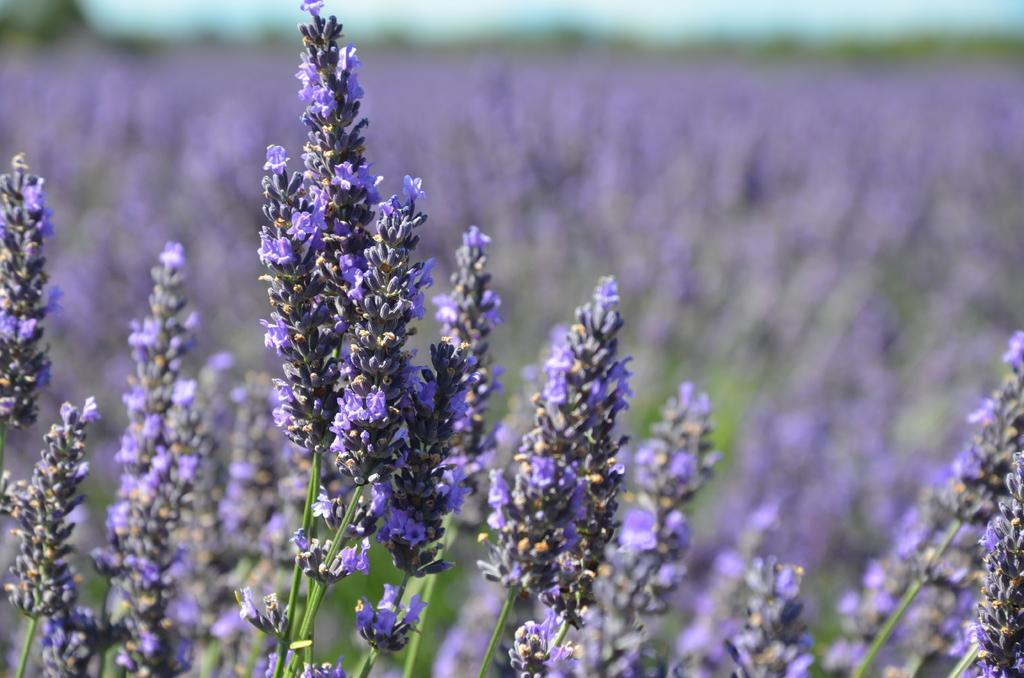What type of plants are in the image? There are flower plants in the image. What color are the flowers? The flowers are purple in color. What can be seen in the background of the image? The sky is visible in the image. What street is visible in the image? There is no street present in the image; it features flower plants and a visible sky. 